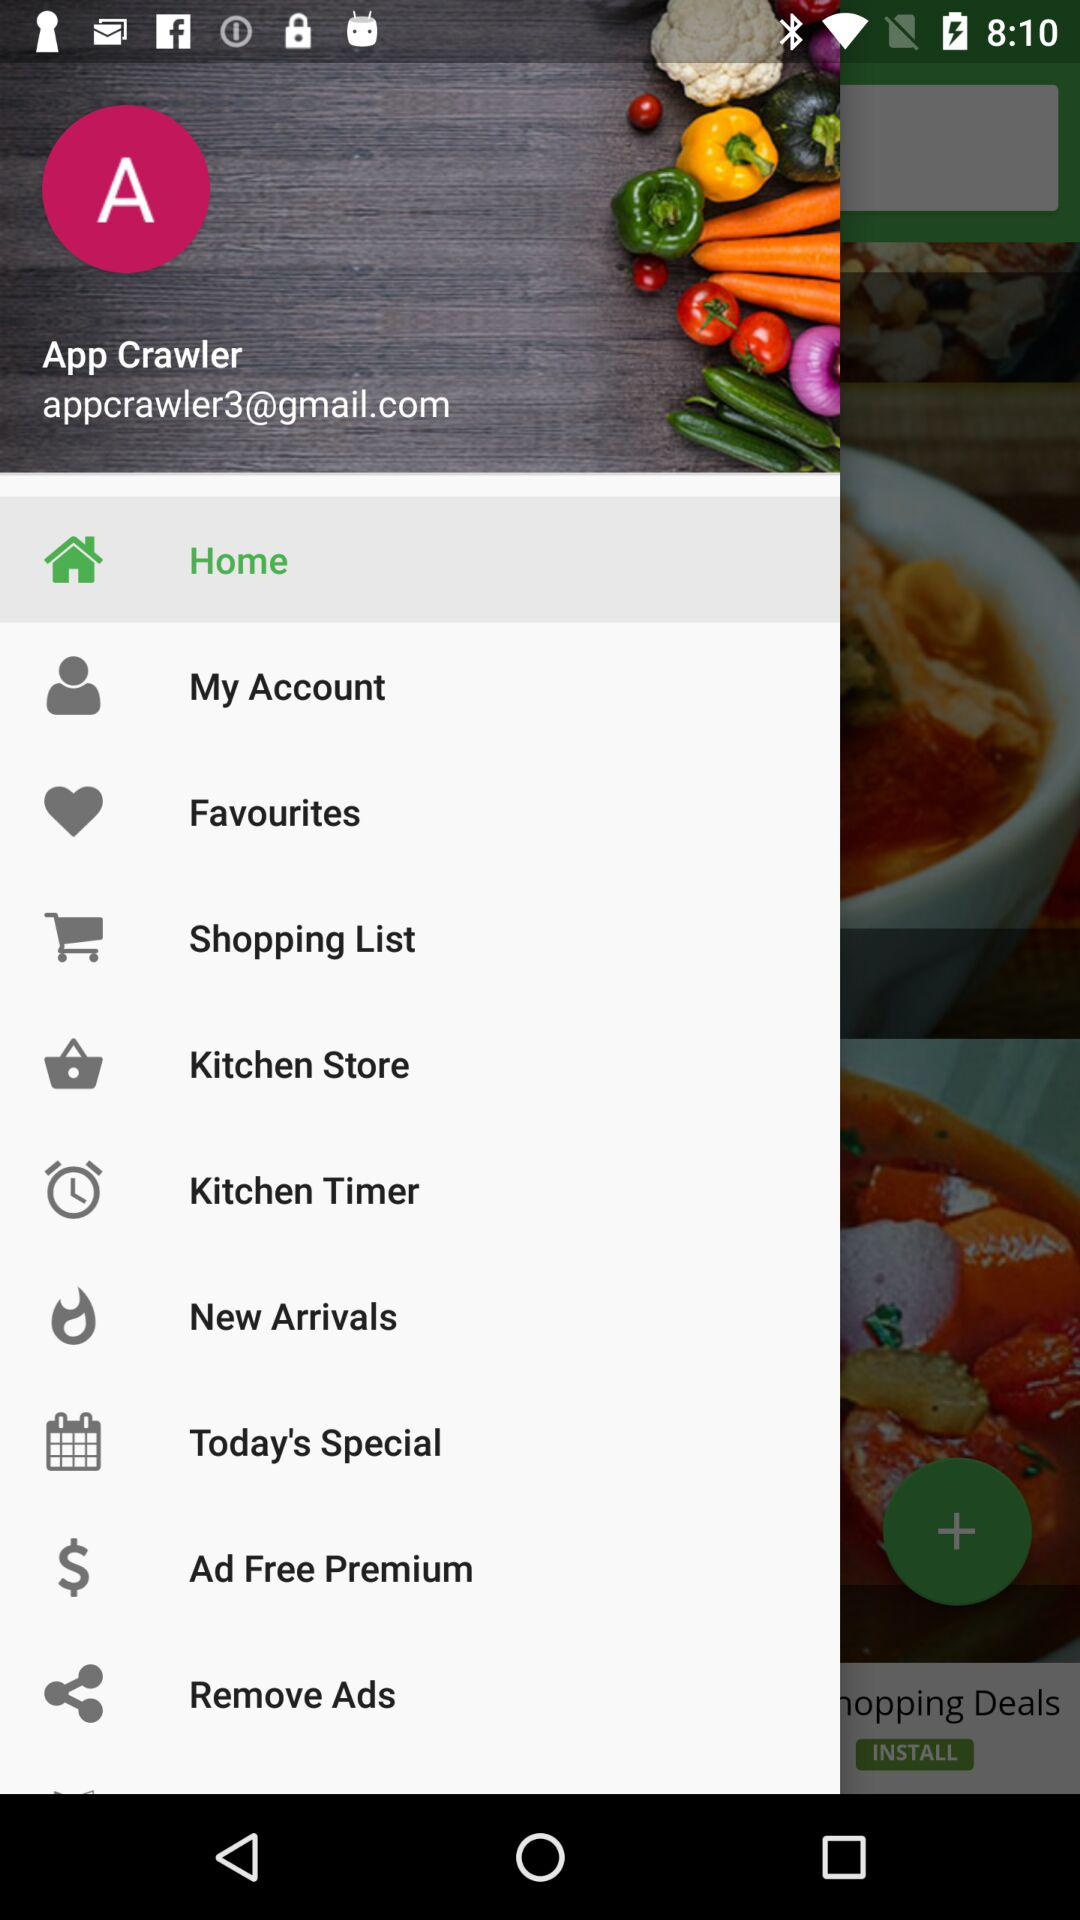What is the user name? The user name is App Crawler. 